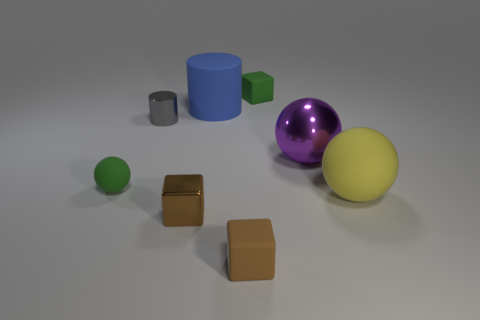There is a purple thing that is the same size as the yellow thing; what is it made of?
Make the answer very short. Metal. There is a rubber block that is to the right of the brown rubber thing; is its color the same as the big cylinder that is behind the large yellow object?
Provide a short and direct response. No. Is there a small thing that has the same shape as the large yellow rubber thing?
Offer a terse response. Yes. There is a gray thing that is the same size as the green matte ball; what is its shape?
Your response must be concise. Cylinder. How many objects have the same color as the big metallic ball?
Offer a very short reply. 0. There is a cylinder that is right of the gray shiny object; what size is it?
Your answer should be very brief. Large. What number of other rubber objects have the same size as the yellow object?
Provide a succinct answer. 1. What color is the cylinder that is the same material as the small green sphere?
Offer a terse response. Blue. Are there fewer yellow balls in front of the small brown matte cube than yellow matte cubes?
Offer a very short reply. No. There is a tiny brown object that is made of the same material as the big purple object; what shape is it?
Ensure brevity in your answer.  Cube. 